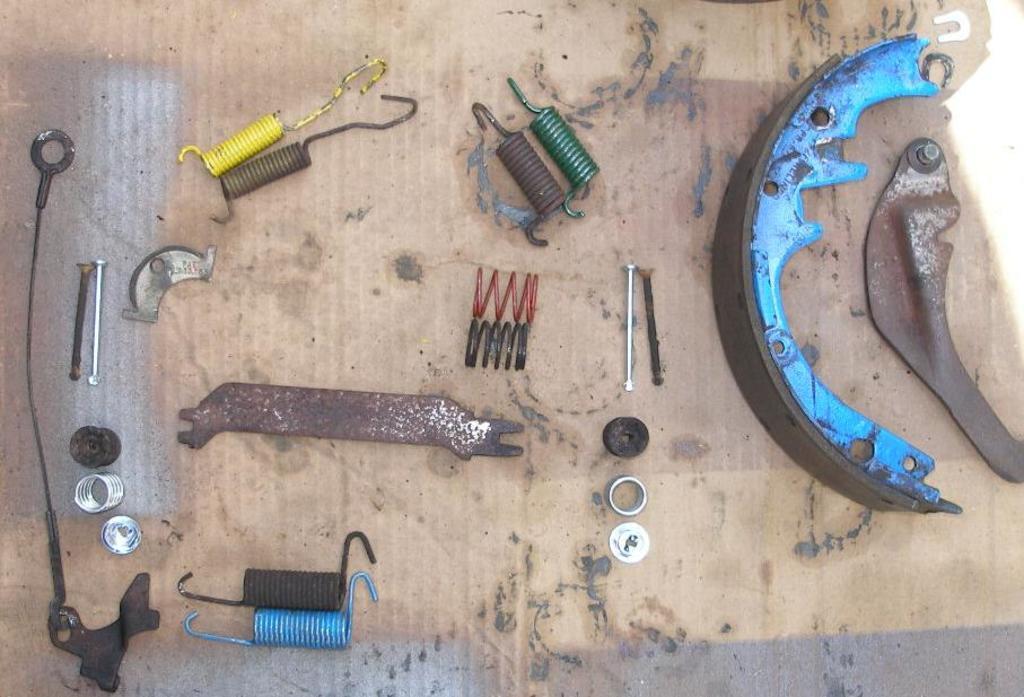In one or two sentences, can you explain what this image depicts? In this image we can see some metal tools and some other objects and these are placed on a surface which looks like a table. 